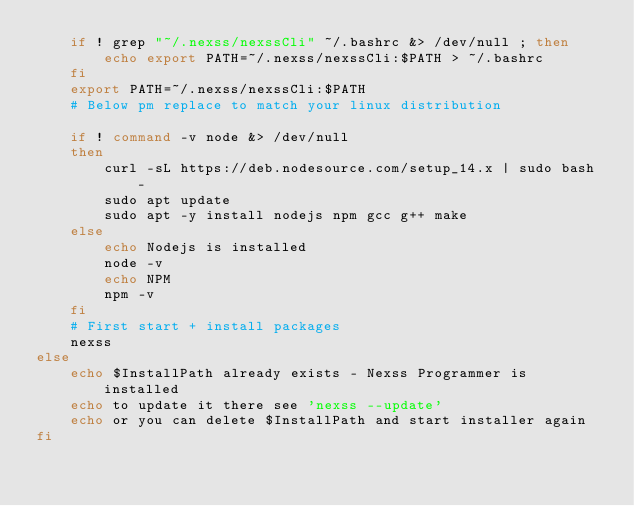Convert code to text. <code><loc_0><loc_0><loc_500><loc_500><_Bash_>    if ! grep "~/.nexss/nexssCli" ~/.bashrc &> /dev/null ; then
        echo export PATH=~/.nexss/nexssCli:$PATH > ~/.bashrc
    fi
    export PATH=~/.nexss/nexssCli:$PATH
    # Below pm replace to match your linux distribution

    if ! command -v node &> /dev/null
    then
        curl -sL https://deb.nodesource.com/setup_14.x | sudo bash -
        sudo apt update
        sudo apt -y install nodejs npm gcc g++ make
    else
        echo Nodejs is installed
        node -v
        echo NPM
        npm -v
    fi   
    # First start + install packages
    nexss
else
    echo $InstallPath already exists - Nexss Programmer is installed
    echo to update it there see 'nexss --update'
    echo or you can delete $InstallPath and start installer again
fi</code> 